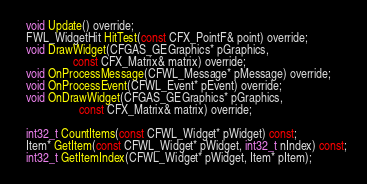<code> <loc_0><loc_0><loc_500><loc_500><_C_>  void Update() override;
  FWL_WidgetHit HitTest(const CFX_PointF& point) override;
  void DrawWidget(CFGAS_GEGraphics* pGraphics,
                  const CFX_Matrix& matrix) override;
  void OnProcessMessage(CFWL_Message* pMessage) override;
  void OnProcessEvent(CFWL_Event* pEvent) override;
  void OnDrawWidget(CFGAS_GEGraphics* pGraphics,
                    const CFX_Matrix& matrix) override;

  int32_t CountItems(const CFWL_Widget* pWidget) const;
  Item* GetItem(const CFWL_Widget* pWidget, int32_t nIndex) const;
  int32_t GetItemIndex(CFWL_Widget* pWidget, Item* pItem);</code> 